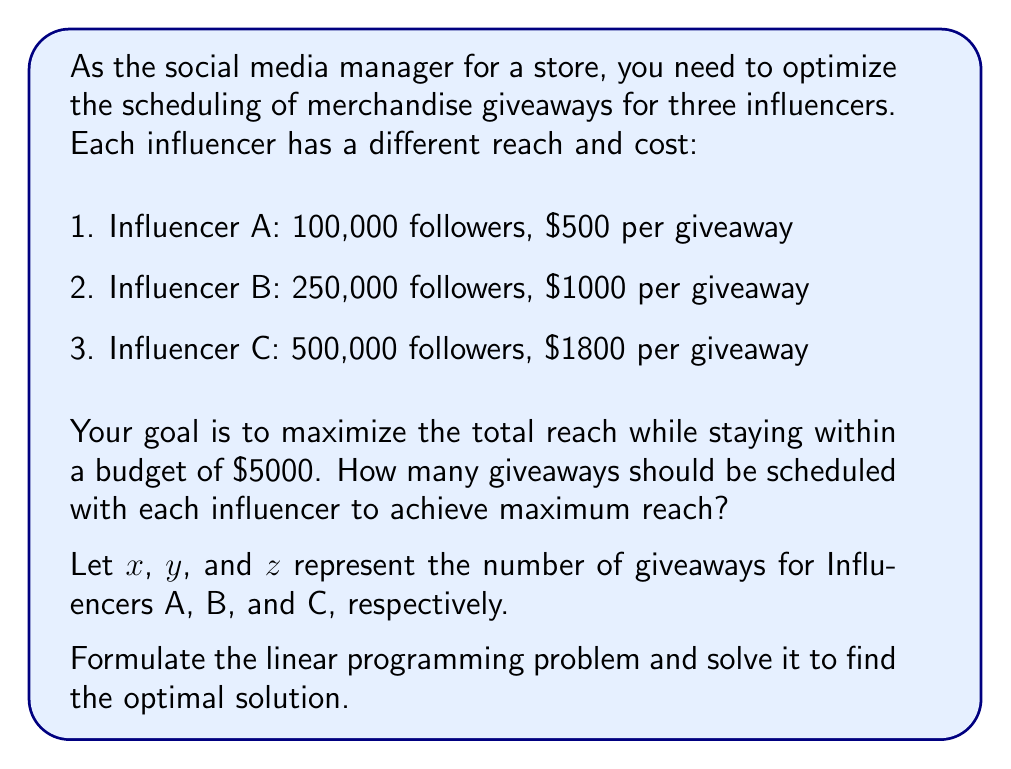Solve this math problem. To solve this problem using Linear Programming, we need to follow these steps:

1. Define the objective function:
   Maximize reach: $100000x + 250000y + 500000z$

2. Define the constraints:
   Budget constraint: $500x + 1000y + 1800z \leq 5000$
   Non-negativity constraints: $x \geq 0$, $y \geq 0$, $z \geq 0$
   Integer constraints: $x$, $y$, and $z$ must be integers

3. Set up the linear programming problem:

   Maximize: $100000x + 250000y + 500000z$
   Subject to:
   $500x + 1000y + 1800z \leq 5000$
   $x, y, z \geq 0$ and integers

4. Solve using the simplex method or a linear programming solver:

   The optimal solution is:
   $x = 2$ (Influencer A)
   $y = 2$ (Influencer B)
   $z = 1$ (Influencer C)

5. Verify the solution:
   Budget used: $500(2) + 1000(2) + 1800(1) = 4800 \leq 5000$
   Total reach: $100000(2) + 250000(2) + 500000(1) = 1,200,000$

This solution maximizes the reach while staying within the budget constraint.
Answer: Influencer A: 2 giveaways, Influencer B: 2 giveaways, Influencer C: 1 giveaway 